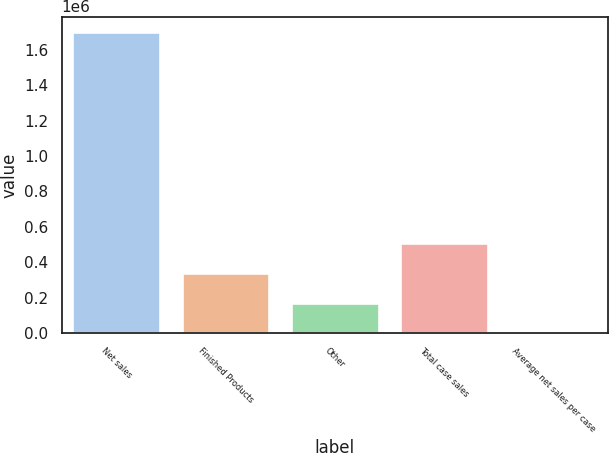Convert chart. <chart><loc_0><loc_0><loc_500><loc_500><bar_chart><fcel>Net sales<fcel>Finished Products<fcel>Other<fcel>Total case sales<fcel>Average net sales per case<nl><fcel>1.70323e+06<fcel>340654<fcel>170332<fcel>510976<fcel>10.34<nl></chart> 